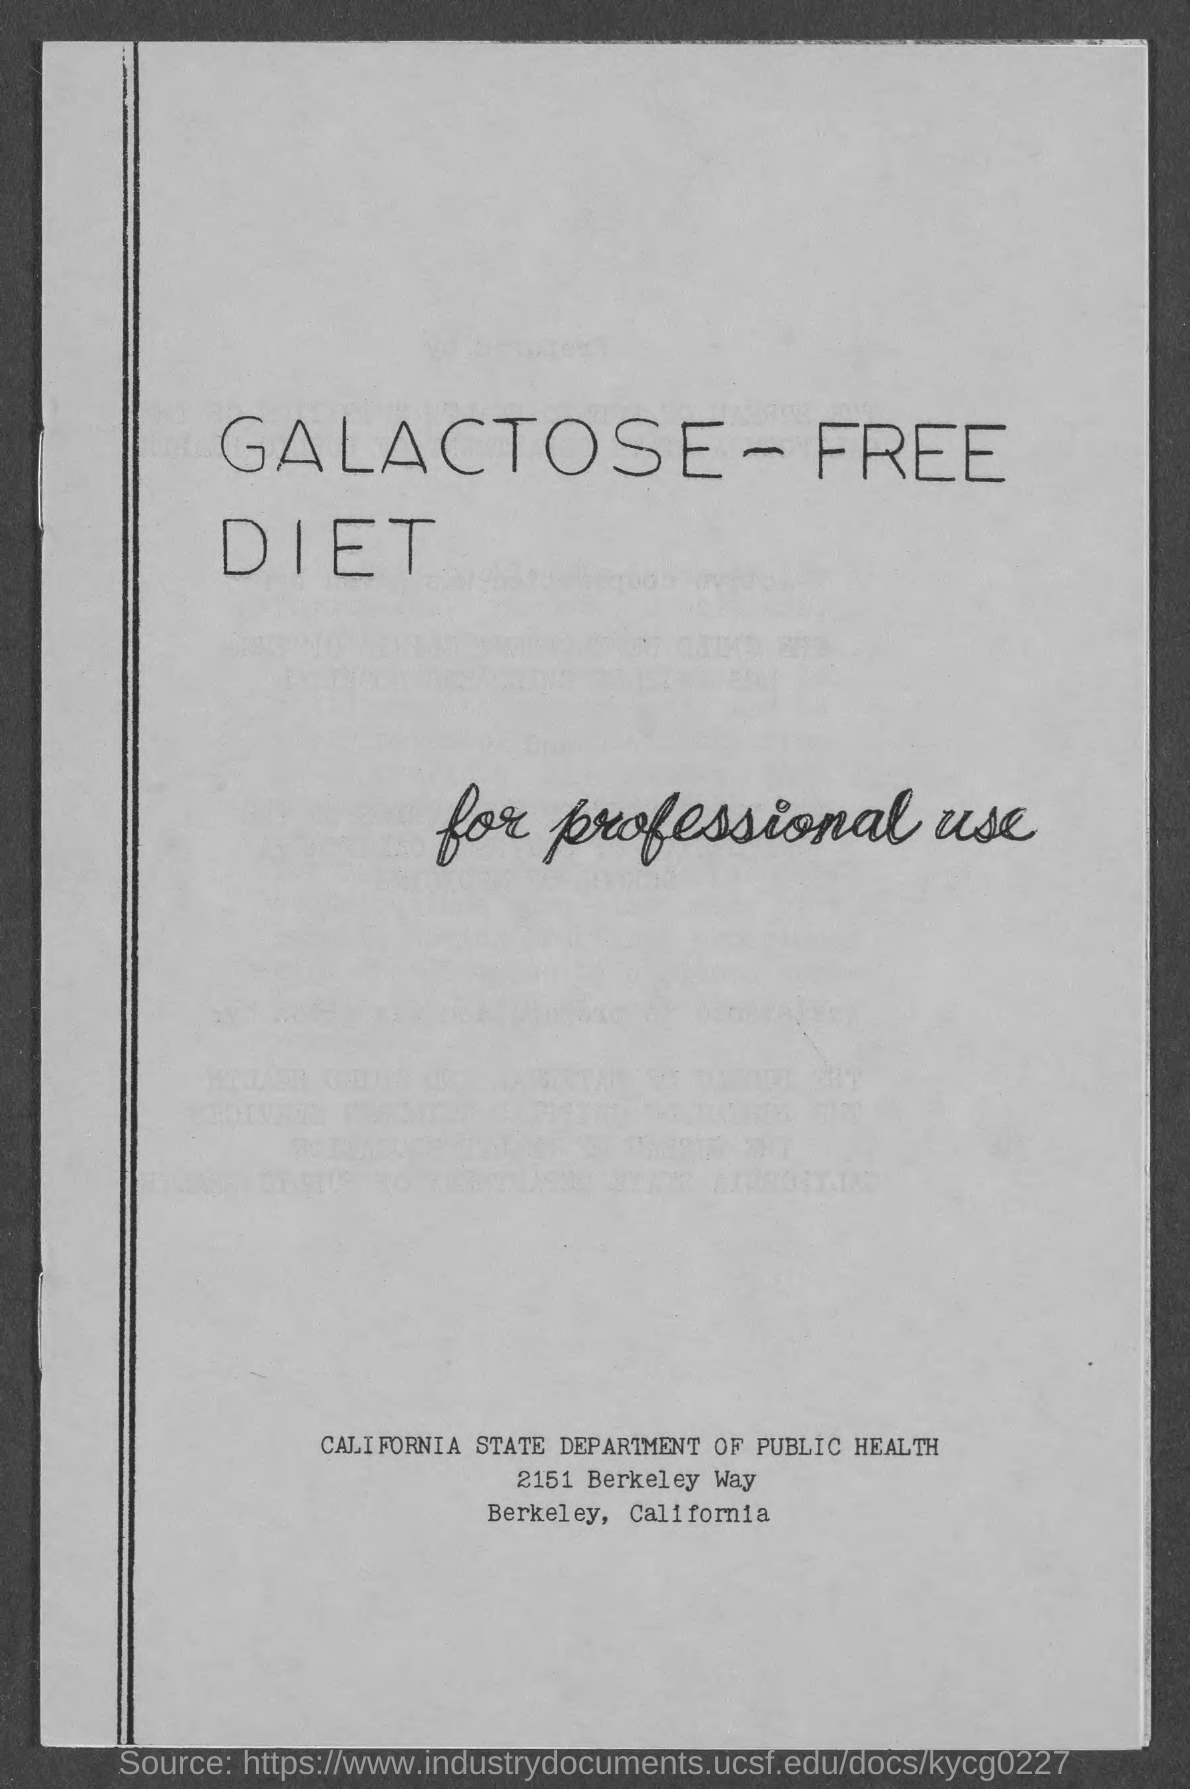Identify some key points in this picture. The first digit in the number written near Berkeley in the document is 2. This document belongs to the California public health department. The department of Public Health in California is mentioned in the document. In the document, the word "Berkeley" is mentioned, and the question asks about the largest digit in a number that is near this word. The question is asking for information about a number and its largest digit. The state mentioned in the document is California. 